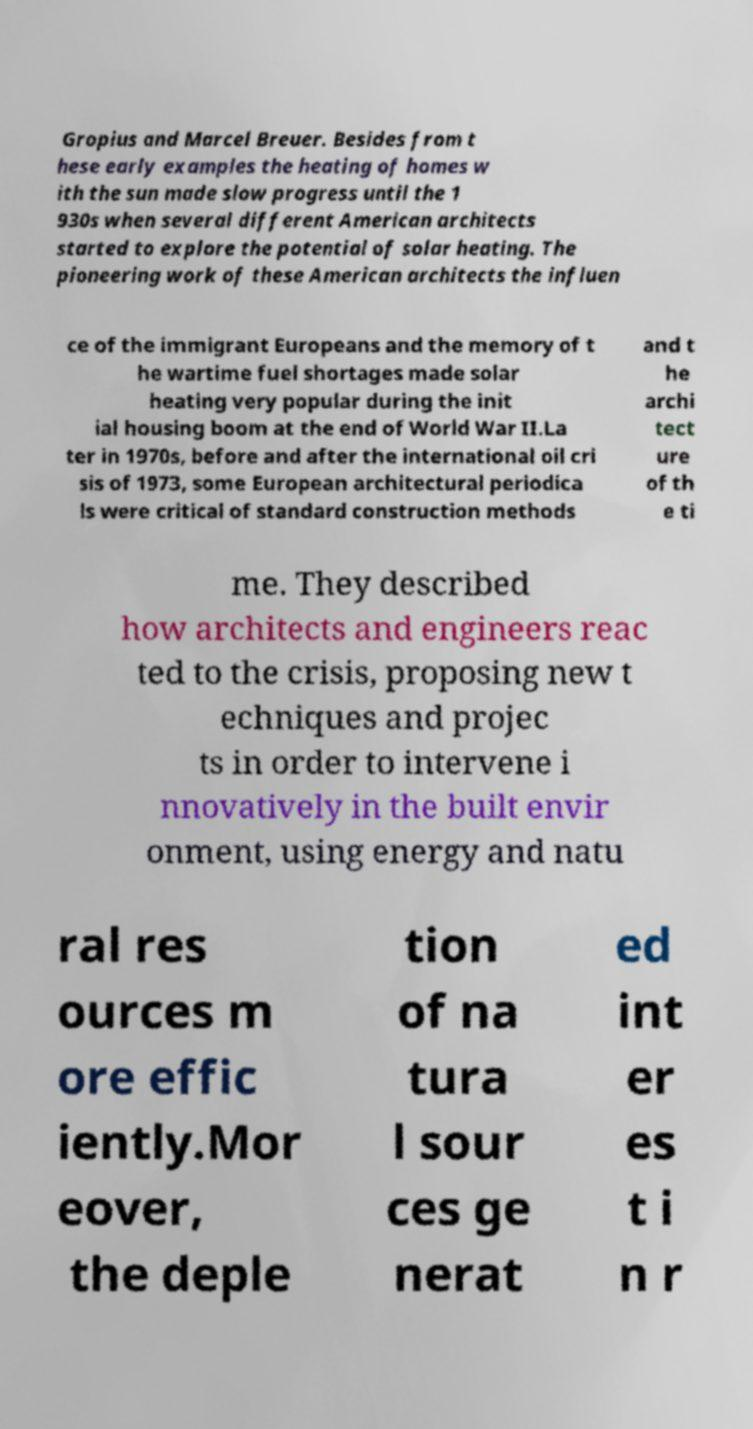Can you accurately transcribe the text from the provided image for me? Gropius and Marcel Breuer. Besides from t hese early examples the heating of homes w ith the sun made slow progress until the 1 930s when several different American architects started to explore the potential of solar heating. The pioneering work of these American architects the influen ce of the immigrant Europeans and the memory of t he wartime fuel shortages made solar heating very popular during the init ial housing boom at the end of World War II.La ter in 1970s, before and after the international oil cri sis of 1973, some European architectural periodica ls were critical of standard construction methods and t he archi tect ure of th e ti me. They described how architects and engineers reac ted to the crisis, proposing new t echniques and projec ts in order to intervene i nnovatively in the built envir onment, using energy and natu ral res ources m ore effic iently.Mor eover, the deple tion of na tura l sour ces ge nerat ed int er es t i n r 